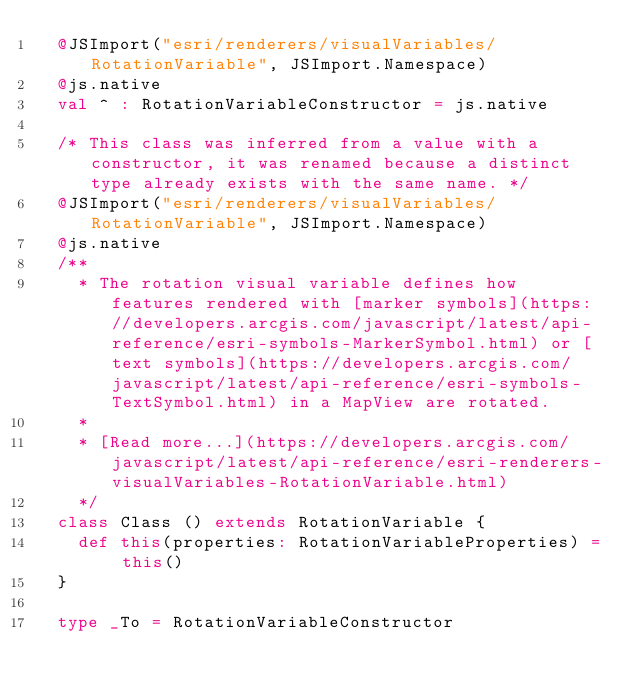<code> <loc_0><loc_0><loc_500><loc_500><_Scala_>  @JSImport("esri/renderers/visualVariables/RotationVariable", JSImport.Namespace)
  @js.native
  val ^ : RotationVariableConstructor = js.native
  
  /* This class was inferred from a value with a constructor, it was renamed because a distinct type already exists with the same name. */
  @JSImport("esri/renderers/visualVariables/RotationVariable", JSImport.Namespace)
  @js.native
  /**
    * The rotation visual variable defines how features rendered with [marker symbols](https://developers.arcgis.com/javascript/latest/api-reference/esri-symbols-MarkerSymbol.html) or [text symbols](https://developers.arcgis.com/javascript/latest/api-reference/esri-symbols-TextSymbol.html) in a MapView are rotated.
    *
    * [Read more...](https://developers.arcgis.com/javascript/latest/api-reference/esri-renderers-visualVariables-RotationVariable.html)
    */
  class Class () extends RotationVariable {
    def this(properties: RotationVariableProperties) = this()
  }
  
  type _To = RotationVariableConstructor
  </code> 